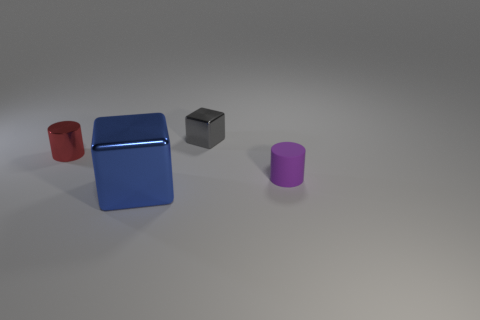Subtract 1 cylinders. How many cylinders are left? 1 Subtract all gray cubes. How many cubes are left? 1 Subtract 0 blue cylinders. How many objects are left? 4 Subtract all gray cylinders. Subtract all brown spheres. How many cylinders are left? 2 Subtract all cyan cubes. How many yellow cylinders are left? 0 Subtract all red shiny spheres. Subtract all purple objects. How many objects are left? 3 Add 1 small metallic cubes. How many small metallic cubes are left? 2 Add 2 large purple shiny objects. How many large purple shiny objects exist? 2 Add 1 big yellow cubes. How many objects exist? 5 